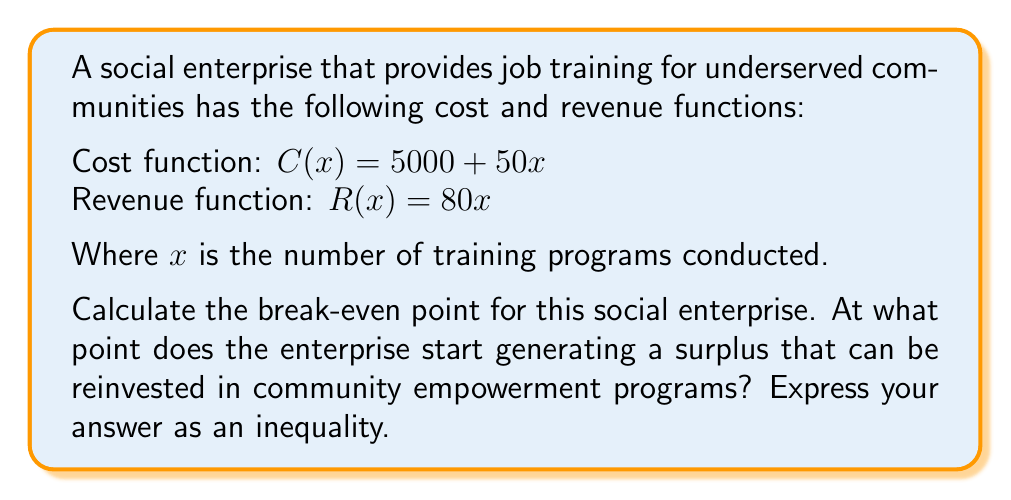Give your solution to this math problem. To find the break-even point, we need to determine when the revenue equals or exceeds the cost. We can set up an inequality:

$$R(x) \geq C(x)$$

Substituting the given functions:

$$80x \geq 5000 + 50x$$

Solving the inequality:

1) Subtract $50x$ from both sides:
   $$30x \geq 5000$$

2) Divide both sides by 30:
   $$x \geq \frac{5000}{30}$$

3) Simplify:
   $$x \geq 166.67$$

Since $x$ represents the number of training programs and must be a whole number, we round up to the nearest integer.

The break-even point occurs when the enterprise conducts 167 or more training programs. At this point, the revenue will equal or exceed the costs, and any additional programs will generate a surplus that can be reinvested in community empowerment initiatives.
Answer: $x \geq 167$, where $x$ is the number of training programs conducted. 